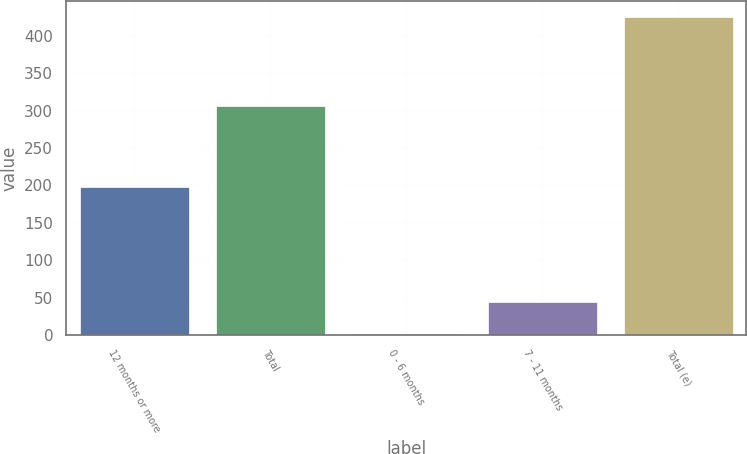Convert chart to OTSL. <chart><loc_0><loc_0><loc_500><loc_500><bar_chart><fcel>12 months or more<fcel>Total<fcel>0 - 6 months<fcel>7 - 11 months<fcel>Total (e)<nl><fcel>198<fcel>306<fcel>2<fcel>44.3<fcel>425<nl></chart> 